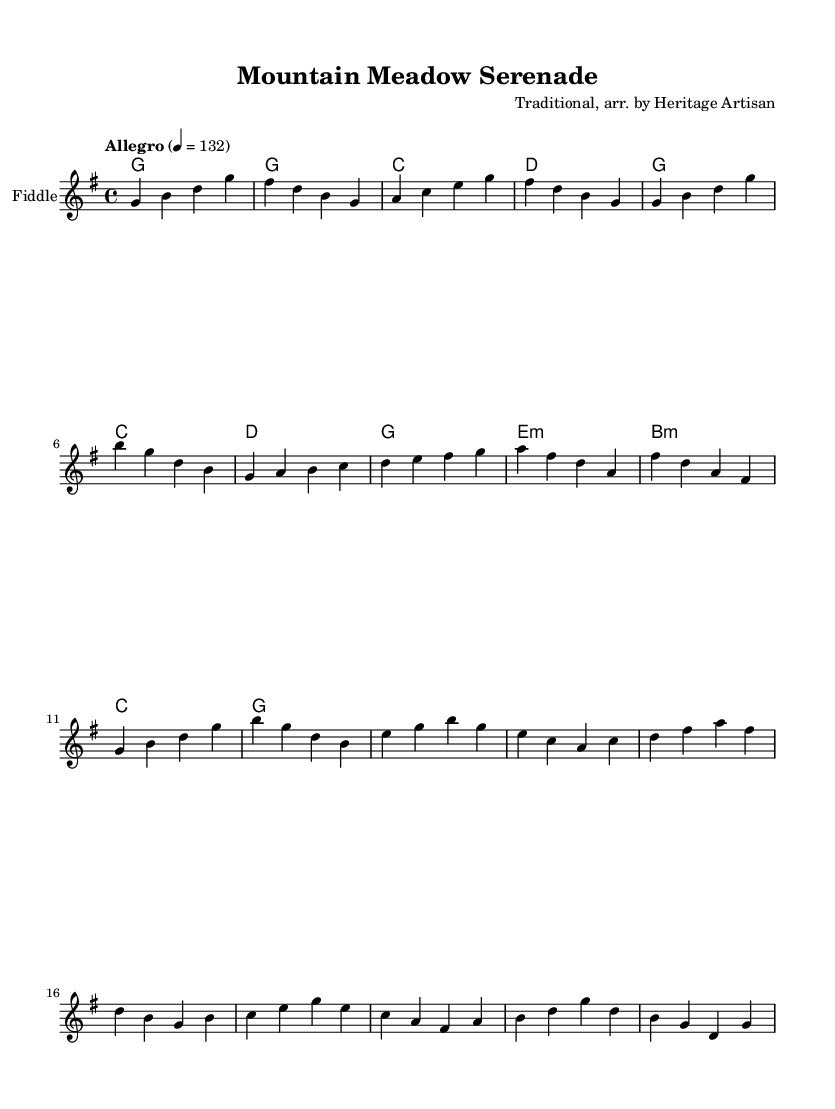What is the key signature of this music? The key signature is G major, which has one sharp (F#). This can be determined by looking at the key signature indicated at the beginning of the music sheet.
Answer: G major What is the time signature of this music? The time signature is 4/4, which means there are four beats in a measure and the quarter note gets one beat. This is clearly marked at the beginning of the score.
Answer: 4/4 What is the tempo marking for this piece? The tempo marking is "Allegro," which indicates a fast and lively tempo. This is specified at the beginning of the sheet music.
Answer: Allegro How many bars are in the A section of the piece? The A section consists of 8 bars, which can be counted by evaluating the measures within the designated A section.
Answer: 8 bars Which instruments are featured in this score? The featured instrument is the Fiddle, as indicated at the start of the staff. The chord section serves as accompaniment for the fiddle.
Answer: Fiddle What is the first chord in the song? The first chord in the piece is G major, as shown in the chord progression at the beginning. It is noted in the chord mode section right after the intro.
Answer: G major What type of song is this? The song is a traditional bluegrass instrumental, which is suggested by the arrangement style and instrumentation suited for celebrating rural landscapes and natural beauty.
Answer: Bluegrass 